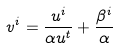<formula> <loc_0><loc_0><loc_500><loc_500>v ^ { i } = \frac { u ^ { i } } { \alpha u ^ { t } } + \frac { \beta ^ { i } } { \alpha }</formula> 